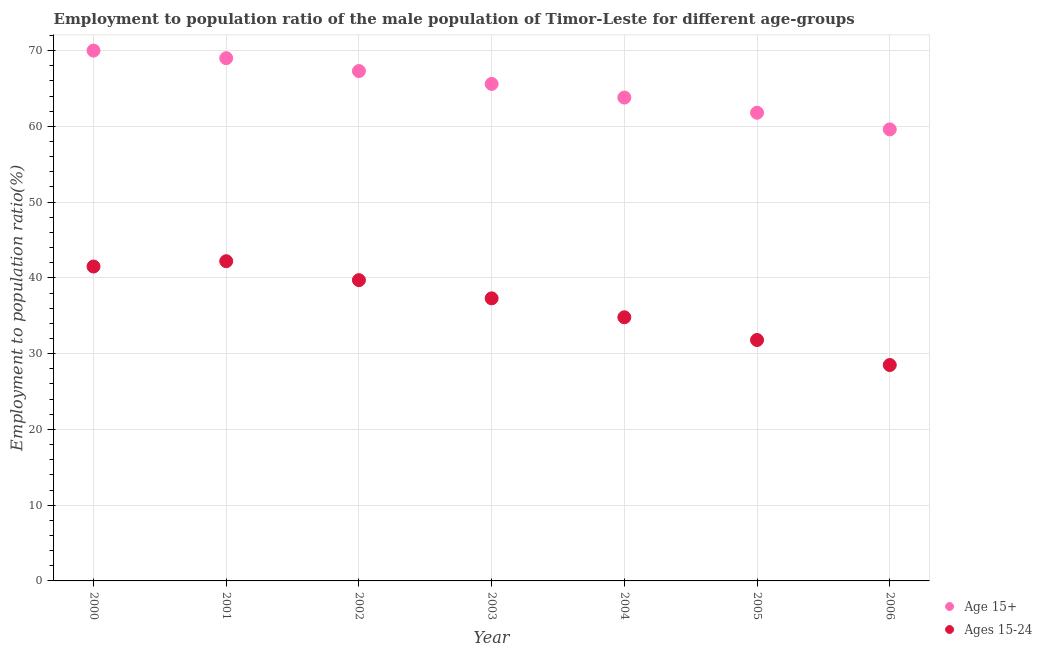How many different coloured dotlines are there?
Your answer should be very brief. 2. Is the number of dotlines equal to the number of legend labels?
Give a very brief answer. Yes. What is the employment to population ratio(age 15+) in 2001?
Offer a very short reply. 69. Across all years, what is the maximum employment to population ratio(age 15-24)?
Give a very brief answer. 42.2. Across all years, what is the minimum employment to population ratio(age 15+)?
Offer a very short reply. 59.6. What is the total employment to population ratio(age 15+) in the graph?
Ensure brevity in your answer.  457.1. What is the difference between the employment to population ratio(age 15-24) in 2000 and that in 2002?
Provide a succinct answer. 1.8. What is the difference between the employment to population ratio(age 15-24) in 2001 and the employment to population ratio(age 15+) in 2004?
Your response must be concise. -21.6. What is the average employment to population ratio(age 15-24) per year?
Make the answer very short. 36.54. In the year 2004, what is the difference between the employment to population ratio(age 15-24) and employment to population ratio(age 15+)?
Offer a terse response. -29. In how many years, is the employment to population ratio(age 15-24) greater than 62 %?
Give a very brief answer. 0. What is the ratio of the employment to population ratio(age 15-24) in 2001 to that in 2005?
Provide a succinct answer. 1.33. Is the difference between the employment to population ratio(age 15-24) in 2003 and 2004 greater than the difference between the employment to population ratio(age 15+) in 2003 and 2004?
Give a very brief answer. Yes. What is the difference between the highest and the lowest employment to population ratio(age 15-24)?
Offer a terse response. 13.7. Does the employment to population ratio(age 15-24) monotonically increase over the years?
Offer a terse response. No. Is the employment to population ratio(age 15+) strictly greater than the employment to population ratio(age 15-24) over the years?
Keep it short and to the point. Yes. Does the graph contain any zero values?
Provide a succinct answer. No. Where does the legend appear in the graph?
Your answer should be very brief. Bottom right. What is the title of the graph?
Keep it short and to the point. Employment to population ratio of the male population of Timor-Leste for different age-groups. What is the Employment to population ratio(%) in Ages 15-24 in 2000?
Provide a short and direct response. 41.5. What is the Employment to population ratio(%) in Ages 15-24 in 2001?
Your response must be concise. 42.2. What is the Employment to population ratio(%) in Age 15+ in 2002?
Offer a terse response. 67.3. What is the Employment to population ratio(%) in Ages 15-24 in 2002?
Your response must be concise. 39.7. What is the Employment to population ratio(%) in Age 15+ in 2003?
Your answer should be very brief. 65.6. What is the Employment to population ratio(%) of Ages 15-24 in 2003?
Give a very brief answer. 37.3. What is the Employment to population ratio(%) in Age 15+ in 2004?
Give a very brief answer. 63.8. What is the Employment to population ratio(%) in Ages 15-24 in 2004?
Keep it short and to the point. 34.8. What is the Employment to population ratio(%) of Age 15+ in 2005?
Your response must be concise. 61.8. What is the Employment to population ratio(%) in Ages 15-24 in 2005?
Give a very brief answer. 31.8. What is the Employment to population ratio(%) of Age 15+ in 2006?
Offer a very short reply. 59.6. Across all years, what is the maximum Employment to population ratio(%) in Ages 15-24?
Make the answer very short. 42.2. Across all years, what is the minimum Employment to population ratio(%) of Age 15+?
Your answer should be very brief. 59.6. What is the total Employment to population ratio(%) of Age 15+ in the graph?
Your answer should be compact. 457.1. What is the total Employment to population ratio(%) of Ages 15-24 in the graph?
Keep it short and to the point. 255.8. What is the difference between the Employment to population ratio(%) in Age 15+ in 2000 and that in 2002?
Make the answer very short. 2.7. What is the difference between the Employment to population ratio(%) in Ages 15-24 in 2000 and that in 2003?
Your answer should be very brief. 4.2. What is the difference between the Employment to population ratio(%) of Age 15+ in 2000 and that in 2005?
Ensure brevity in your answer.  8.2. What is the difference between the Employment to population ratio(%) of Ages 15-24 in 2000 and that in 2005?
Offer a very short reply. 9.7. What is the difference between the Employment to population ratio(%) of Age 15+ in 2001 and that in 2002?
Your response must be concise. 1.7. What is the difference between the Employment to population ratio(%) of Age 15+ in 2001 and that in 2005?
Provide a succinct answer. 7.2. What is the difference between the Employment to population ratio(%) of Age 15+ in 2001 and that in 2006?
Make the answer very short. 9.4. What is the difference between the Employment to population ratio(%) in Age 15+ in 2002 and that in 2003?
Make the answer very short. 1.7. What is the difference between the Employment to population ratio(%) of Age 15+ in 2002 and that in 2004?
Give a very brief answer. 3.5. What is the difference between the Employment to population ratio(%) in Age 15+ in 2002 and that in 2006?
Your answer should be compact. 7.7. What is the difference between the Employment to population ratio(%) in Ages 15-24 in 2002 and that in 2006?
Provide a short and direct response. 11.2. What is the difference between the Employment to population ratio(%) in Ages 15-24 in 2003 and that in 2004?
Offer a terse response. 2.5. What is the difference between the Employment to population ratio(%) in Ages 15-24 in 2003 and that in 2005?
Provide a short and direct response. 5.5. What is the difference between the Employment to population ratio(%) in Age 15+ in 2003 and that in 2006?
Provide a succinct answer. 6. What is the difference between the Employment to population ratio(%) in Ages 15-24 in 2003 and that in 2006?
Provide a succinct answer. 8.8. What is the difference between the Employment to population ratio(%) in Age 15+ in 2004 and that in 2006?
Keep it short and to the point. 4.2. What is the difference between the Employment to population ratio(%) in Ages 15-24 in 2005 and that in 2006?
Provide a short and direct response. 3.3. What is the difference between the Employment to population ratio(%) in Age 15+ in 2000 and the Employment to population ratio(%) in Ages 15-24 in 2001?
Ensure brevity in your answer.  27.8. What is the difference between the Employment to population ratio(%) in Age 15+ in 2000 and the Employment to population ratio(%) in Ages 15-24 in 2002?
Keep it short and to the point. 30.3. What is the difference between the Employment to population ratio(%) in Age 15+ in 2000 and the Employment to population ratio(%) in Ages 15-24 in 2003?
Keep it short and to the point. 32.7. What is the difference between the Employment to population ratio(%) in Age 15+ in 2000 and the Employment to population ratio(%) in Ages 15-24 in 2004?
Give a very brief answer. 35.2. What is the difference between the Employment to population ratio(%) of Age 15+ in 2000 and the Employment to population ratio(%) of Ages 15-24 in 2005?
Make the answer very short. 38.2. What is the difference between the Employment to population ratio(%) in Age 15+ in 2000 and the Employment to population ratio(%) in Ages 15-24 in 2006?
Your answer should be very brief. 41.5. What is the difference between the Employment to population ratio(%) in Age 15+ in 2001 and the Employment to population ratio(%) in Ages 15-24 in 2002?
Offer a terse response. 29.3. What is the difference between the Employment to population ratio(%) of Age 15+ in 2001 and the Employment to population ratio(%) of Ages 15-24 in 2003?
Make the answer very short. 31.7. What is the difference between the Employment to population ratio(%) in Age 15+ in 2001 and the Employment to population ratio(%) in Ages 15-24 in 2004?
Your answer should be very brief. 34.2. What is the difference between the Employment to population ratio(%) in Age 15+ in 2001 and the Employment to population ratio(%) in Ages 15-24 in 2005?
Offer a terse response. 37.2. What is the difference between the Employment to population ratio(%) in Age 15+ in 2001 and the Employment to population ratio(%) in Ages 15-24 in 2006?
Keep it short and to the point. 40.5. What is the difference between the Employment to population ratio(%) in Age 15+ in 2002 and the Employment to population ratio(%) in Ages 15-24 in 2003?
Give a very brief answer. 30. What is the difference between the Employment to population ratio(%) of Age 15+ in 2002 and the Employment to population ratio(%) of Ages 15-24 in 2004?
Make the answer very short. 32.5. What is the difference between the Employment to population ratio(%) of Age 15+ in 2002 and the Employment to population ratio(%) of Ages 15-24 in 2005?
Give a very brief answer. 35.5. What is the difference between the Employment to population ratio(%) of Age 15+ in 2002 and the Employment to population ratio(%) of Ages 15-24 in 2006?
Offer a terse response. 38.8. What is the difference between the Employment to population ratio(%) of Age 15+ in 2003 and the Employment to population ratio(%) of Ages 15-24 in 2004?
Provide a succinct answer. 30.8. What is the difference between the Employment to population ratio(%) of Age 15+ in 2003 and the Employment to population ratio(%) of Ages 15-24 in 2005?
Offer a terse response. 33.8. What is the difference between the Employment to population ratio(%) in Age 15+ in 2003 and the Employment to population ratio(%) in Ages 15-24 in 2006?
Offer a terse response. 37.1. What is the difference between the Employment to population ratio(%) of Age 15+ in 2004 and the Employment to population ratio(%) of Ages 15-24 in 2005?
Ensure brevity in your answer.  32. What is the difference between the Employment to population ratio(%) of Age 15+ in 2004 and the Employment to population ratio(%) of Ages 15-24 in 2006?
Make the answer very short. 35.3. What is the difference between the Employment to population ratio(%) of Age 15+ in 2005 and the Employment to population ratio(%) of Ages 15-24 in 2006?
Make the answer very short. 33.3. What is the average Employment to population ratio(%) of Age 15+ per year?
Your answer should be very brief. 65.3. What is the average Employment to population ratio(%) of Ages 15-24 per year?
Your response must be concise. 36.54. In the year 2001, what is the difference between the Employment to population ratio(%) of Age 15+ and Employment to population ratio(%) of Ages 15-24?
Provide a short and direct response. 26.8. In the year 2002, what is the difference between the Employment to population ratio(%) of Age 15+ and Employment to population ratio(%) of Ages 15-24?
Keep it short and to the point. 27.6. In the year 2003, what is the difference between the Employment to population ratio(%) of Age 15+ and Employment to population ratio(%) of Ages 15-24?
Your response must be concise. 28.3. In the year 2005, what is the difference between the Employment to population ratio(%) in Age 15+ and Employment to population ratio(%) in Ages 15-24?
Provide a succinct answer. 30. In the year 2006, what is the difference between the Employment to population ratio(%) of Age 15+ and Employment to population ratio(%) of Ages 15-24?
Ensure brevity in your answer.  31.1. What is the ratio of the Employment to population ratio(%) of Age 15+ in 2000 to that in 2001?
Keep it short and to the point. 1.01. What is the ratio of the Employment to population ratio(%) in Ages 15-24 in 2000 to that in 2001?
Your response must be concise. 0.98. What is the ratio of the Employment to population ratio(%) of Age 15+ in 2000 to that in 2002?
Your answer should be very brief. 1.04. What is the ratio of the Employment to population ratio(%) in Ages 15-24 in 2000 to that in 2002?
Offer a terse response. 1.05. What is the ratio of the Employment to population ratio(%) of Age 15+ in 2000 to that in 2003?
Keep it short and to the point. 1.07. What is the ratio of the Employment to population ratio(%) of Ages 15-24 in 2000 to that in 2003?
Provide a short and direct response. 1.11. What is the ratio of the Employment to population ratio(%) of Age 15+ in 2000 to that in 2004?
Provide a short and direct response. 1.1. What is the ratio of the Employment to population ratio(%) of Ages 15-24 in 2000 to that in 2004?
Provide a short and direct response. 1.19. What is the ratio of the Employment to population ratio(%) in Age 15+ in 2000 to that in 2005?
Your response must be concise. 1.13. What is the ratio of the Employment to population ratio(%) of Ages 15-24 in 2000 to that in 2005?
Your response must be concise. 1.3. What is the ratio of the Employment to population ratio(%) in Age 15+ in 2000 to that in 2006?
Your answer should be compact. 1.17. What is the ratio of the Employment to population ratio(%) of Ages 15-24 in 2000 to that in 2006?
Your answer should be very brief. 1.46. What is the ratio of the Employment to population ratio(%) of Age 15+ in 2001 to that in 2002?
Your answer should be very brief. 1.03. What is the ratio of the Employment to population ratio(%) of Ages 15-24 in 2001 to that in 2002?
Keep it short and to the point. 1.06. What is the ratio of the Employment to population ratio(%) of Age 15+ in 2001 to that in 2003?
Offer a terse response. 1.05. What is the ratio of the Employment to population ratio(%) in Ages 15-24 in 2001 to that in 2003?
Offer a terse response. 1.13. What is the ratio of the Employment to population ratio(%) in Age 15+ in 2001 to that in 2004?
Ensure brevity in your answer.  1.08. What is the ratio of the Employment to population ratio(%) in Ages 15-24 in 2001 to that in 2004?
Offer a very short reply. 1.21. What is the ratio of the Employment to population ratio(%) in Age 15+ in 2001 to that in 2005?
Your response must be concise. 1.12. What is the ratio of the Employment to population ratio(%) of Ages 15-24 in 2001 to that in 2005?
Make the answer very short. 1.33. What is the ratio of the Employment to population ratio(%) in Age 15+ in 2001 to that in 2006?
Offer a very short reply. 1.16. What is the ratio of the Employment to population ratio(%) of Ages 15-24 in 2001 to that in 2006?
Your answer should be compact. 1.48. What is the ratio of the Employment to population ratio(%) of Age 15+ in 2002 to that in 2003?
Offer a very short reply. 1.03. What is the ratio of the Employment to population ratio(%) in Ages 15-24 in 2002 to that in 2003?
Give a very brief answer. 1.06. What is the ratio of the Employment to population ratio(%) in Age 15+ in 2002 to that in 2004?
Offer a very short reply. 1.05. What is the ratio of the Employment to population ratio(%) in Ages 15-24 in 2002 to that in 2004?
Your answer should be compact. 1.14. What is the ratio of the Employment to population ratio(%) of Age 15+ in 2002 to that in 2005?
Give a very brief answer. 1.09. What is the ratio of the Employment to population ratio(%) in Ages 15-24 in 2002 to that in 2005?
Provide a short and direct response. 1.25. What is the ratio of the Employment to population ratio(%) of Age 15+ in 2002 to that in 2006?
Ensure brevity in your answer.  1.13. What is the ratio of the Employment to population ratio(%) of Ages 15-24 in 2002 to that in 2006?
Give a very brief answer. 1.39. What is the ratio of the Employment to population ratio(%) of Age 15+ in 2003 to that in 2004?
Give a very brief answer. 1.03. What is the ratio of the Employment to population ratio(%) in Ages 15-24 in 2003 to that in 2004?
Offer a very short reply. 1.07. What is the ratio of the Employment to population ratio(%) in Age 15+ in 2003 to that in 2005?
Provide a succinct answer. 1.06. What is the ratio of the Employment to population ratio(%) in Ages 15-24 in 2003 to that in 2005?
Offer a very short reply. 1.17. What is the ratio of the Employment to population ratio(%) of Age 15+ in 2003 to that in 2006?
Your response must be concise. 1.1. What is the ratio of the Employment to population ratio(%) of Ages 15-24 in 2003 to that in 2006?
Give a very brief answer. 1.31. What is the ratio of the Employment to population ratio(%) in Age 15+ in 2004 to that in 2005?
Offer a terse response. 1.03. What is the ratio of the Employment to population ratio(%) of Ages 15-24 in 2004 to that in 2005?
Your response must be concise. 1.09. What is the ratio of the Employment to population ratio(%) of Age 15+ in 2004 to that in 2006?
Offer a terse response. 1.07. What is the ratio of the Employment to population ratio(%) in Ages 15-24 in 2004 to that in 2006?
Your answer should be very brief. 1.22. What is the ratio of the Employment to population ratio(%) in Age 15+ in 2005 to that in 2006?
Provide a short and direct response. 1.04. What is the ratio of the Employment to population ratio(%) of Ages 15-24 in 2005 to that in 2006?
Give a very brief answer. 1.12. 